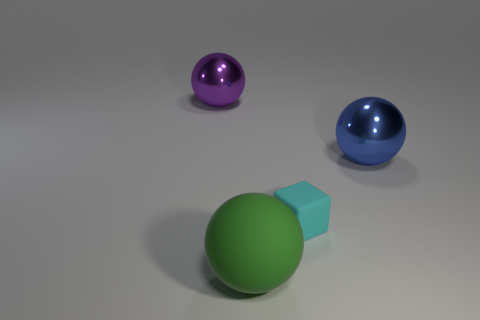There is a cyan thing that is the same material as the green ball; what shape is it?
Your answer should be compact. Cube. Are any large metallic things visible?
Provide a short and direct response. Yes. Is the number of cyan matte objects to the right of the cyan matte object less than the number of green balls that are behind the large green ball?
Provide a succinct answer. No. What shape is the matte thing behind the green rubber ball?
Keep it short and to the point. Cube. Does the green sphere have the same material as the small cube?
Ensure brevity in your answer.  Yes. Is there any other thing that has the same material as the blue sphere?
Give a very brief answer. Yes. There is a big blue object that is the same shape as the green matte object; what is its material?
Your answer should be very brief. Metal. Is the number of big rubber objects that are behind the cyan block less than the number of tiny purple rubber cylinders?
Your response must be concise. No. How many metallic spheres are in front of the big green rubber sphere?
Make the answer very short. 0. There is a large metal object that is in front of the large purple object; is its shape the same as the object left of the rubber sphere?
Give a very brief answer. Yes. 